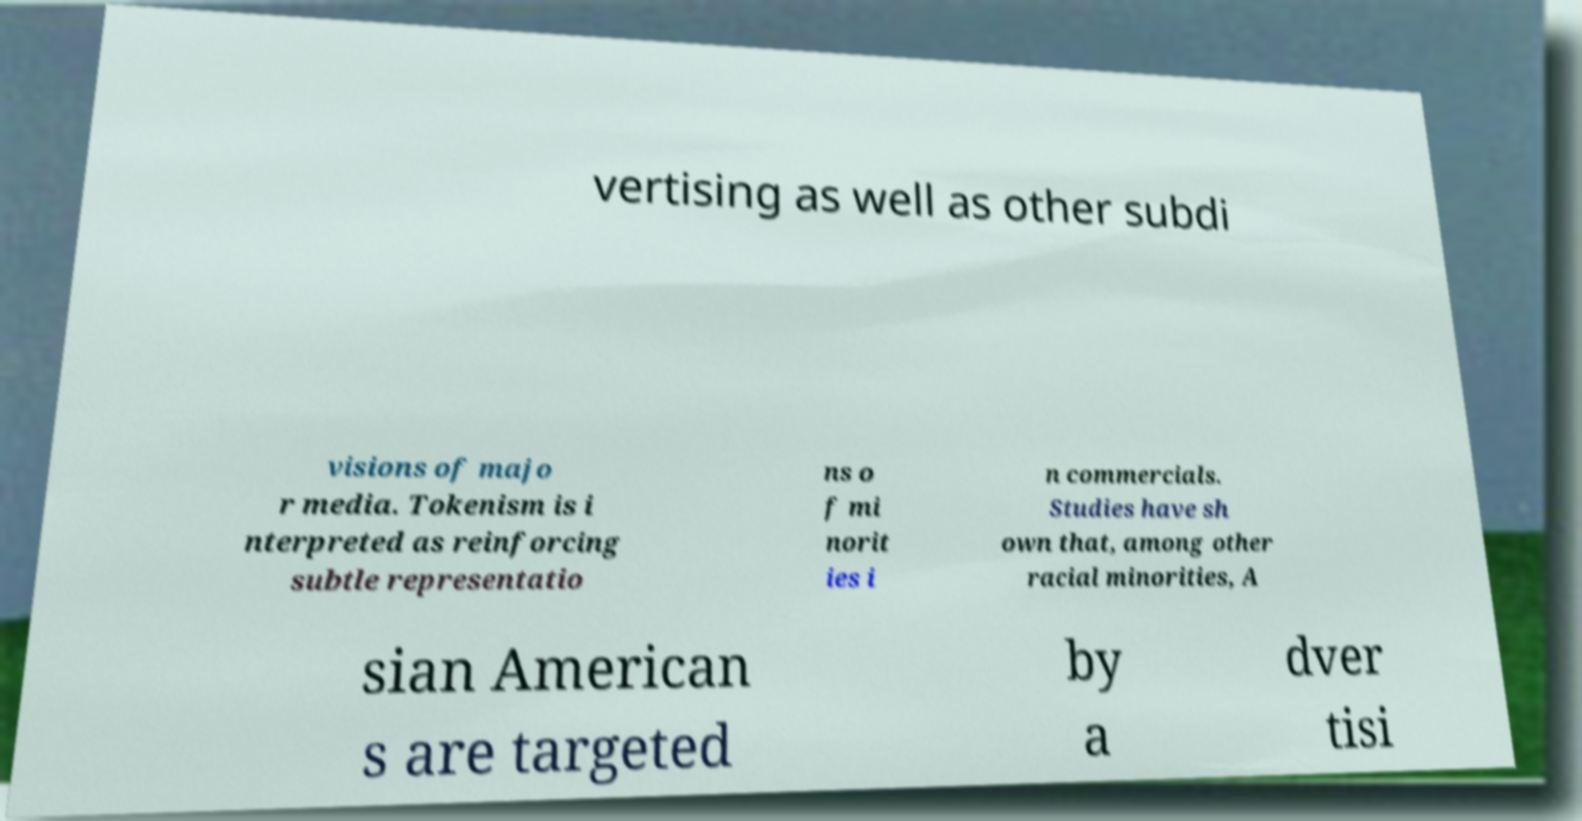There's text embedded in this image that I need extracted. Can you transcribe it verbatim? The visible text in the image says: 'vertising as well as other subdi visions of majo r media. Tokenism is i nterpreted as reinforcing subtle representatio ns o f mi norit ies i n commercials. Studies have sh own that, among other racial minorities, A sian American s are targeted by a dver tisi'. This transcription is partial and may contain errors due to the quality and angle of the image. 